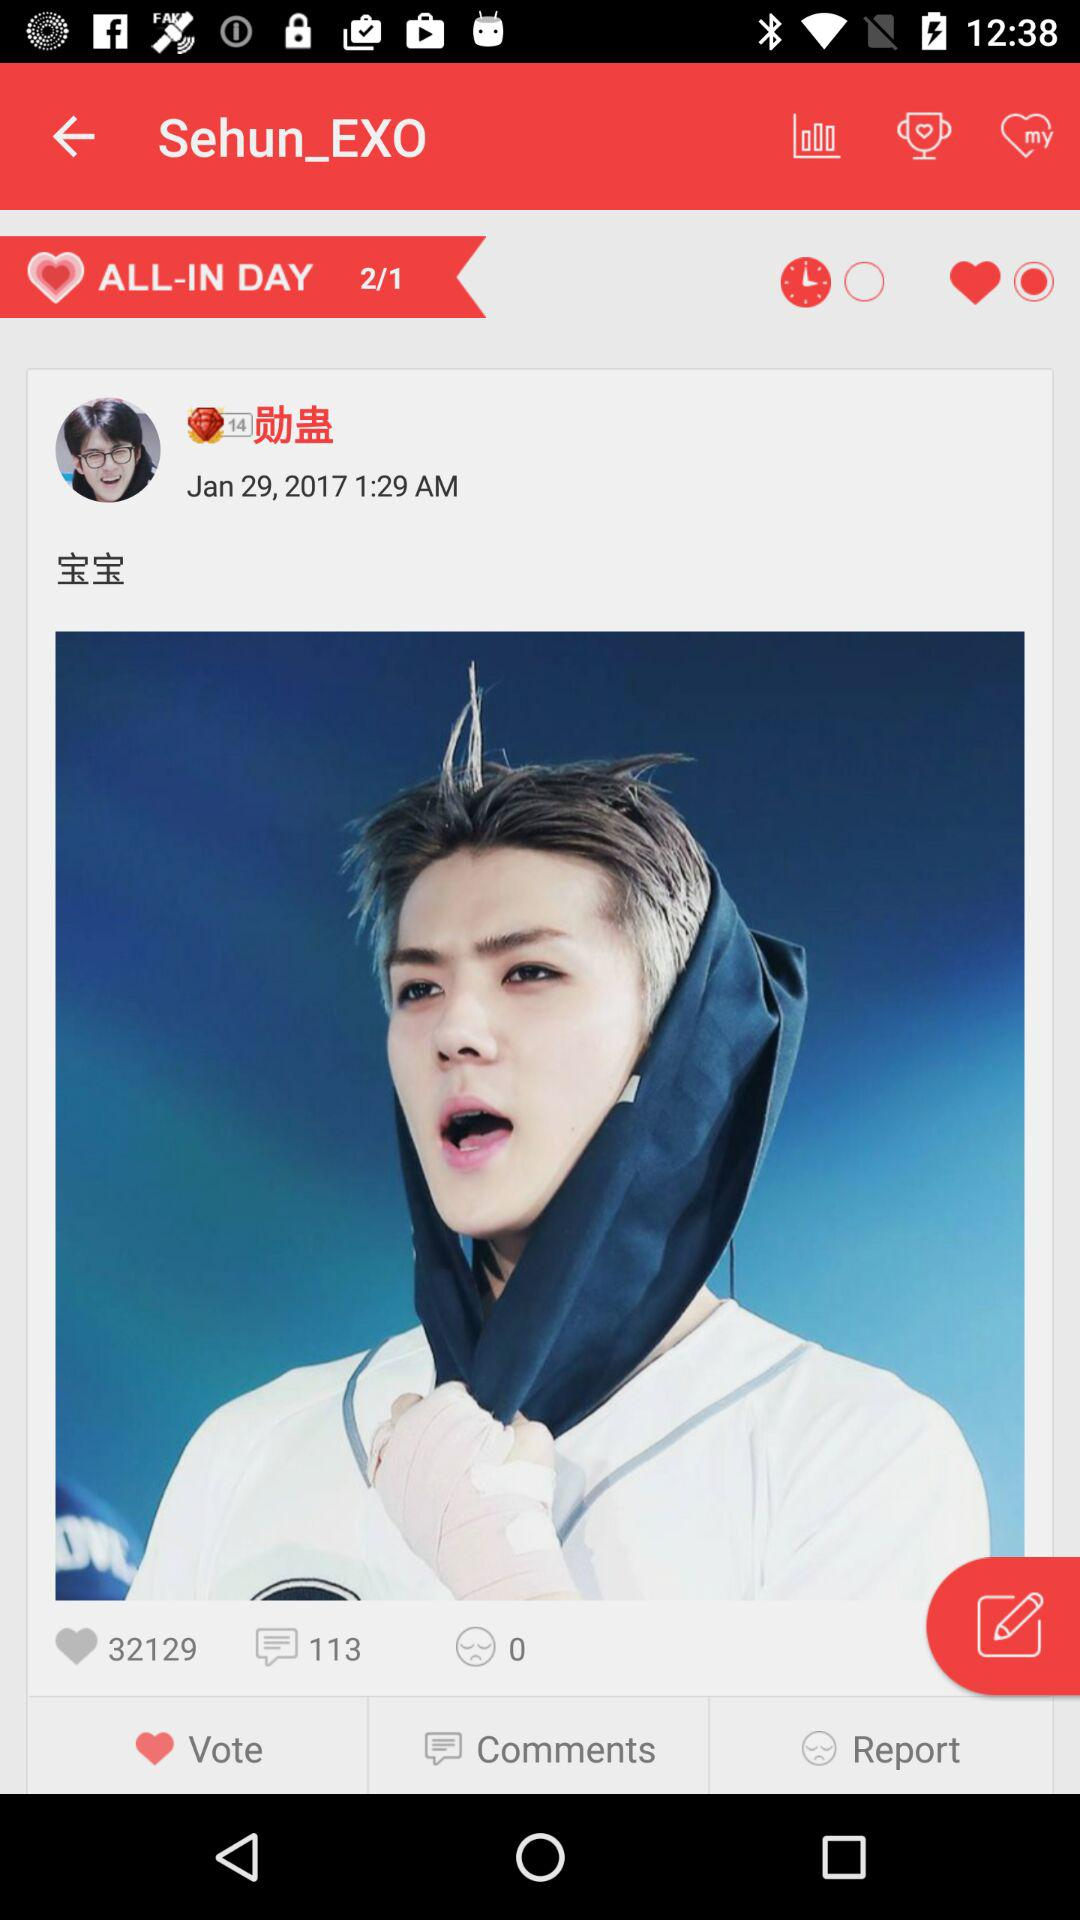What is the time? The time is 1:29 AM. 